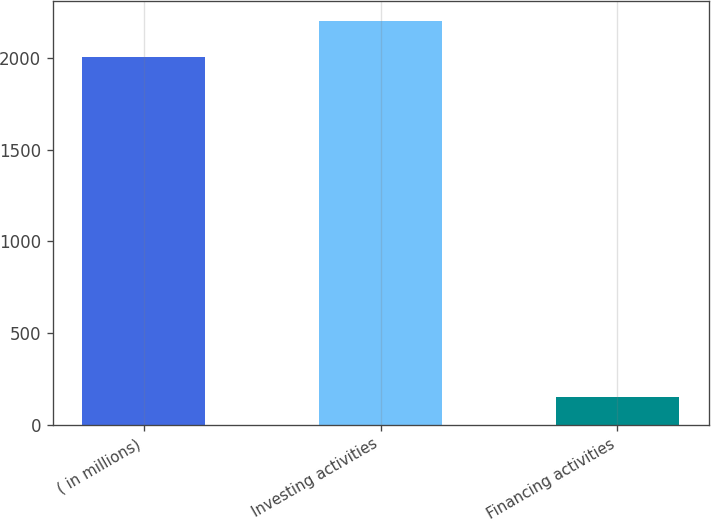<chart> <loc_0><loc_0><loc_500><loc_500><bar_chart><fcel>( in millions)<fcel>Investing activities<fcel>Financing activities<nl><fcel>2006<fcel>2198.2<fcel>152<nl></chart> 